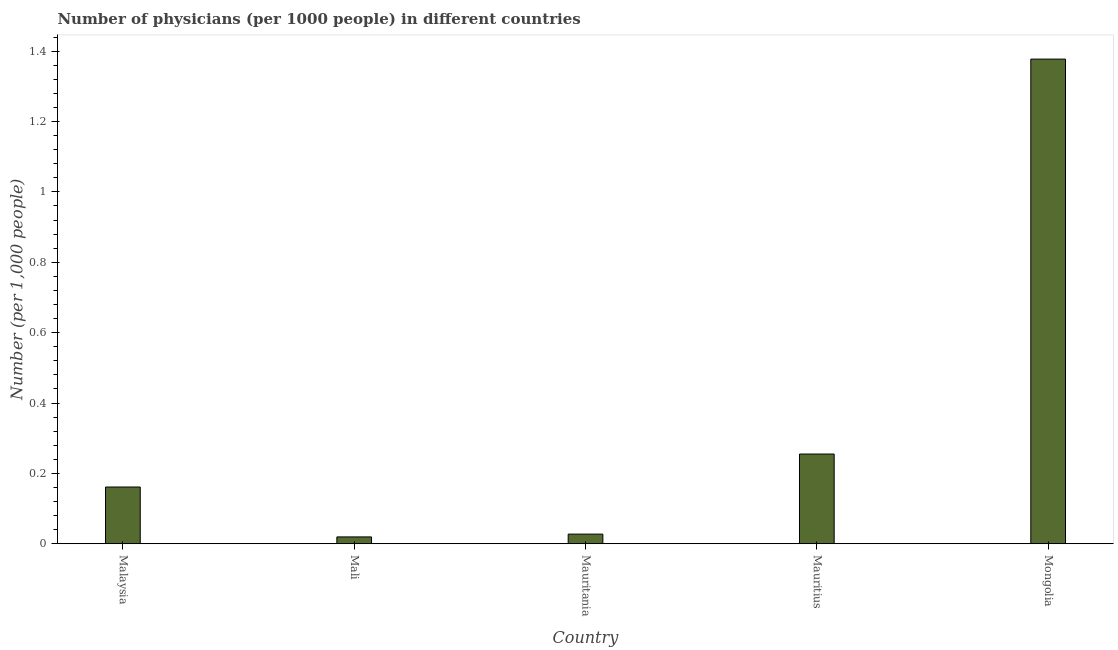Does the graph contain grids?
Offer a terse response. No. What is the title of the graph?
Make the answer very short. Number of physicians (per 1000 people) in different countries. What is the label or title of the X-axis?
Offer a terse response. Country. What is the label or title of the Y-axis?
Your response must be concise. Number (per 1,0 people). What is the number of physicians in Mongolia?
Make the answer very short. 1.38. Across all countries, what is the maximum number of physicians?
Your response must be concise. 1.38. Across all countries, what is the minimum number of physicians?
Your answer should be compact. 0.02. In which country was the number of physicians maximum?
Ensure brevity in your answer.  Mongolia. In which country was the number of physicians minimum?
Make the answer very short. Mali. What is the sum of the number of physicians?
Your answer should be very brief. 1.84. What is the difference between the number of physicians in Mauritania and Mongolia?
Give a very brief answer. -1.35. What is the average number of physicians per country?
Offer a terse response. 0.37. What is the median number of physicians?
Your response must be concise. 0.16. What is the ratio of the number of physicians in Mali to that in Mongolia?
Your answer should be very brief. 0.01. Is the number of physicians in Mali less than that in Mauritania?
Keep it short and to the point. Yes. Is the difference between the number of physicians in Malaysia and Mali greater than the difference between any two countries?
Provide a succinct answer. No. What is the difference between the highest and the second highest number of physicians?
Provide a succinct answer. 1.12. Is the sum of the number of physicians in Mauritania and Mongolia greater than the maximum number of physicians across all countries?
Keep it short and to the point. Yes. What is the difference between the highest and the lowest number of physicians?
Your answer should be very brief. 1.36. Are all the bars in the graph horizontal?
Give a very brief answer. No. How many countries are there in the graph?
Your answer should be very brief. 5. Are the values on the major ticks of Y-axis written in scientific E-notation?
Offer a very short reply. No. What is the Number (per 1,000 people) of Malaysia?
Your answer should be compact. 0.16. What is the Number (per 1,000 people) of Mali?
Ensure brevity in your answer.  0.02. What is the Number (per 1,000 people) in Mauritania?
Ensure brevity in your answer.  0.03. What is the Number (per 1,000 people) in Mauritius?
Your response must be concise. 0.25. What is the Number (per 1,000 people) in Mongolia?
Keep it short and to the point. 1.38. What is the difference between the Number (per 1,000 people) in Malaysia and Mali?
Your answer should be compact. 0.14. What is the difference between the Number (per 1,000 people) in Malaysia and Mauritania?
Your answer should be very brief. 0.13. What is the difference between the Number (per 1,000 people) in Malaysia and Mauritius?
Offer a terse response. -0.09. What is the difference between the Number (per 1,000 people) in Malaysia and Mongolia?
Your response must be concise. -1.22. What is the difference between the Number (per 1,000 people) in Mali and Mauritania?
Your response must be concise. -0.01. What is the difference between the Number (per 1,000 people) in Mali and Mauritius?
Keep it short and to the point. -0.24. What is the difference between the Number (per 1,000 people) in Mali and Mongolia?
Ensure brevity in your answer.  -1.36. What is the difference between the Number (per 1,000 people) in Mauritania and Mauritius?
Ensure brevity in your answer.  -0.23. What is the difference between the Number (per 1,000 people) in Mauritania and Mongolia?
Offer a very short reply. -1.35. What is the difference between the Number (per 1,000 people) in Mauritius and Mongolia?
Provide a succinct answer. -1.12. What is the ratio of the Number (per 1,000 people) in Malaysia to that in Mali?
Give a very brief answer. 8.3. What is the ratio of the Number (per 1,000 people) in Malaysia to that in Mauritania?
Your answer should be very brief. 5.89. What is the ratio of the Number (per 1,000 people) in Malaysia to that in Mauritius?
Your response must be concise. 0.63. What is the ratio of the Number (per 1,000 people) in Malaysia to that in Mongolia?
Give a very brief answer. 0.12. What is the ratio of the Number (per 1,000 people) in Mali to that in Mauritania?
Your response must be concise. 0.71. What is the ratio of the Number (per 1,000 people) in Mali to that in Mauritius?
Make the answer very short. 0.08. What is the ratio of the Number (per 1,000 people) in Mali to that in Mongolia?
Provide a short and direct response. 0.01. What is the ratio of the Number (per 1,000 people) in Mauritania to that in Mauritius?
Keep it short and to the point. 0.11. What is the ratio of the Number (per 1,000 people) in Mauritania to that in Mongolia?
Keep it short and to the point. 0.02. What is the ratio of the Number (per 1,000 people) in Mauritius to that in Mongolia?
Provide a short and direct response. 0.18. 